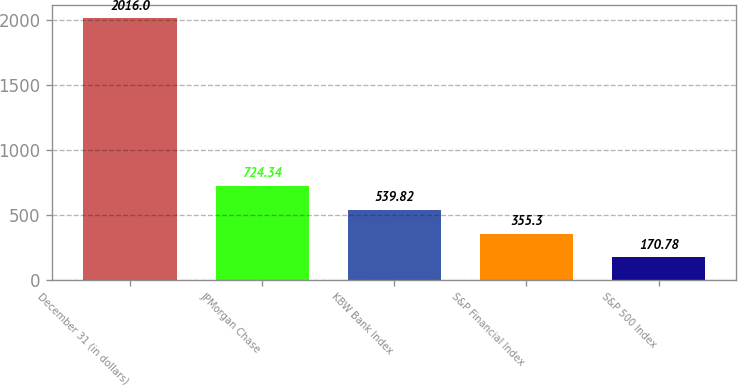Convert chart. <chart><loc_0><loc_0><loc_500><loc_500><bar_chart><fcel>December 31 (in dollars)<fcel>JPMorgan Chase<fcel>KBW Bank Index<fcel>S&P Financial Index<fcel>S&P 500 Index<nl><fcel>2016<fcel>724.34<fcel>539.82<fcel>355.3<fcel>170.78<nl></chart> 